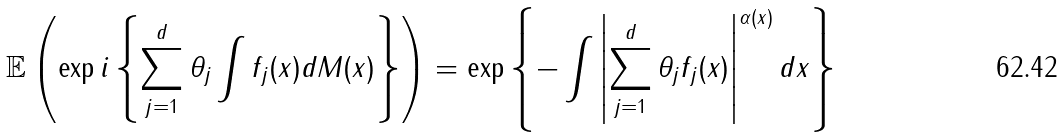<formula> <loc_0><loc_0><loc_500><loc_500>\mathbb { E } \left ( \exp i \left \{ \sum _ { j = 1 } ^ { d } \theta _ { j } \int f _ { j } ( x ) d M ( x ) \right \} \right ) = \exp \left \{ - \int \left | \sum _ { j = 1 } ^ { d } \theta _ { j } f _ { j } ( x ) \right | ^ { \alpha ( x ) } d x \right \}</formula> 